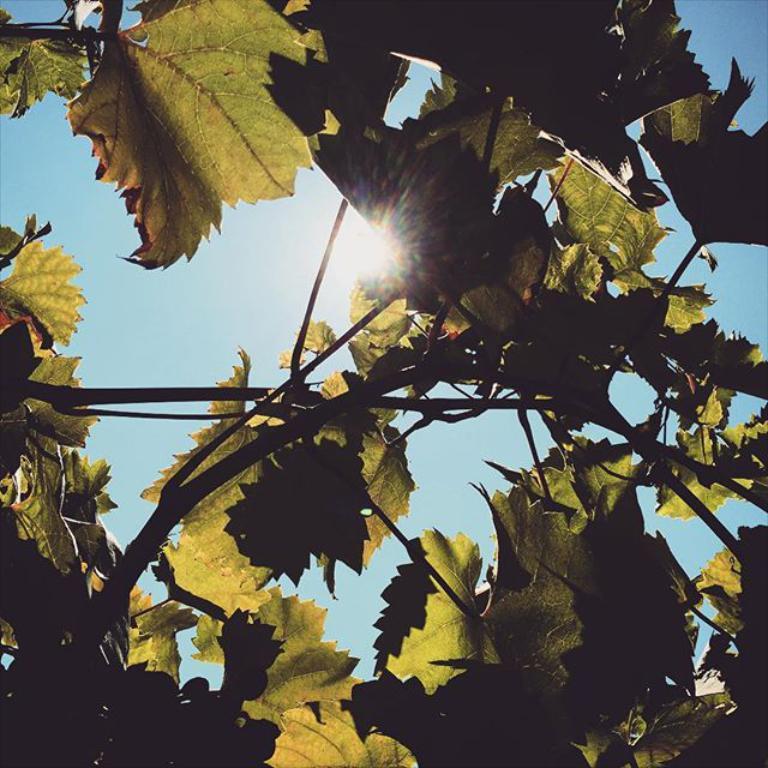How would you summarize this image in a sentence or two? In this image we can see leaves, branches, sky and sun. 